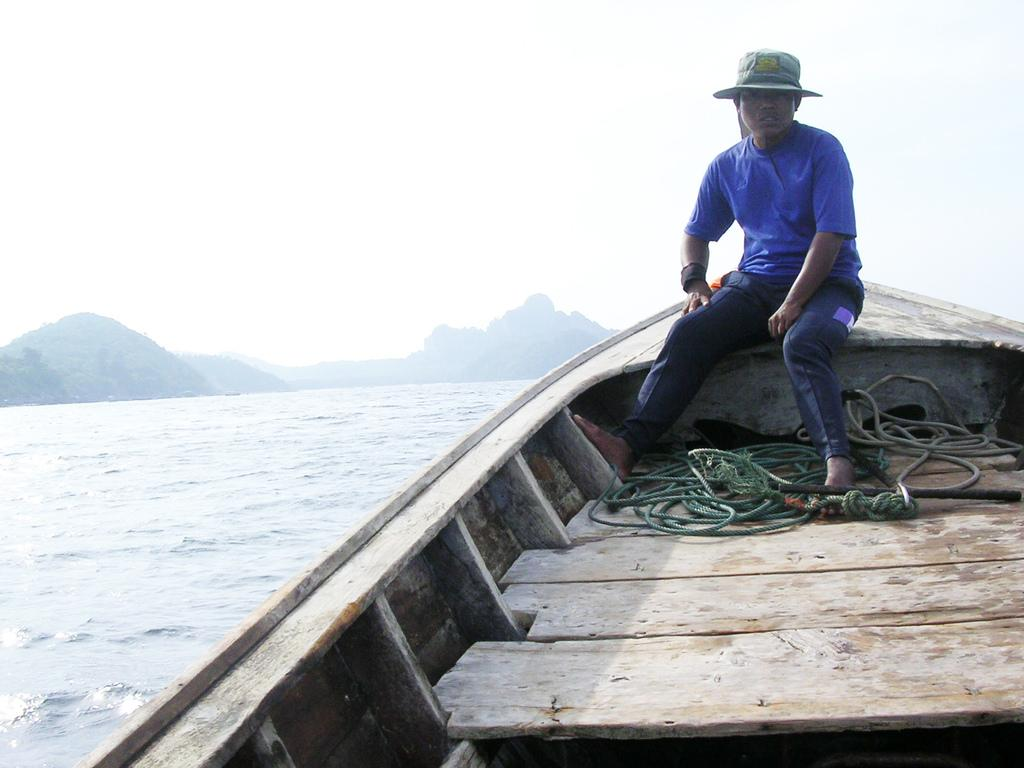What is the main subject of the image? The main subject of the image is a boat. What can be seen attached to the boat? There is a green-colored rope attached to the boat. Who is in the boat? A man is sitting in the boat. What is the man wearing? The man is wearing a blue dress and blue pants. What accessory is the man wearing? The man is wearing a hat. What is visible in the background of the image? Water is visible in the background of the image. What direction is the zephyr blowing in the image? There is no mention of a zephyr in the image, so it cannot be determined which direction it might be blowing. 